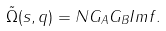<formula> <loc_0><loc_0><loc_500><loc_500>\tilde { \Omega } ( s , q ) = N G _ { A } G _ { B } I m f .</formula> 